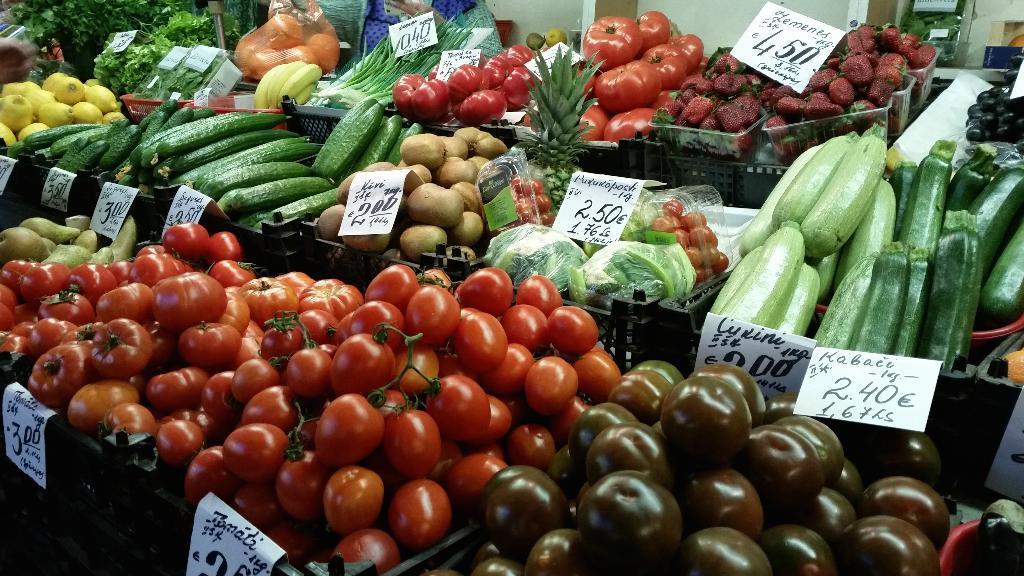In one or two sentences, can you explain what this image depicts? There are tomatoes, potatoes, bananas, fruits and other vegetables arranged in the baskets along with the cards. In the background, there is wall and other objects. 